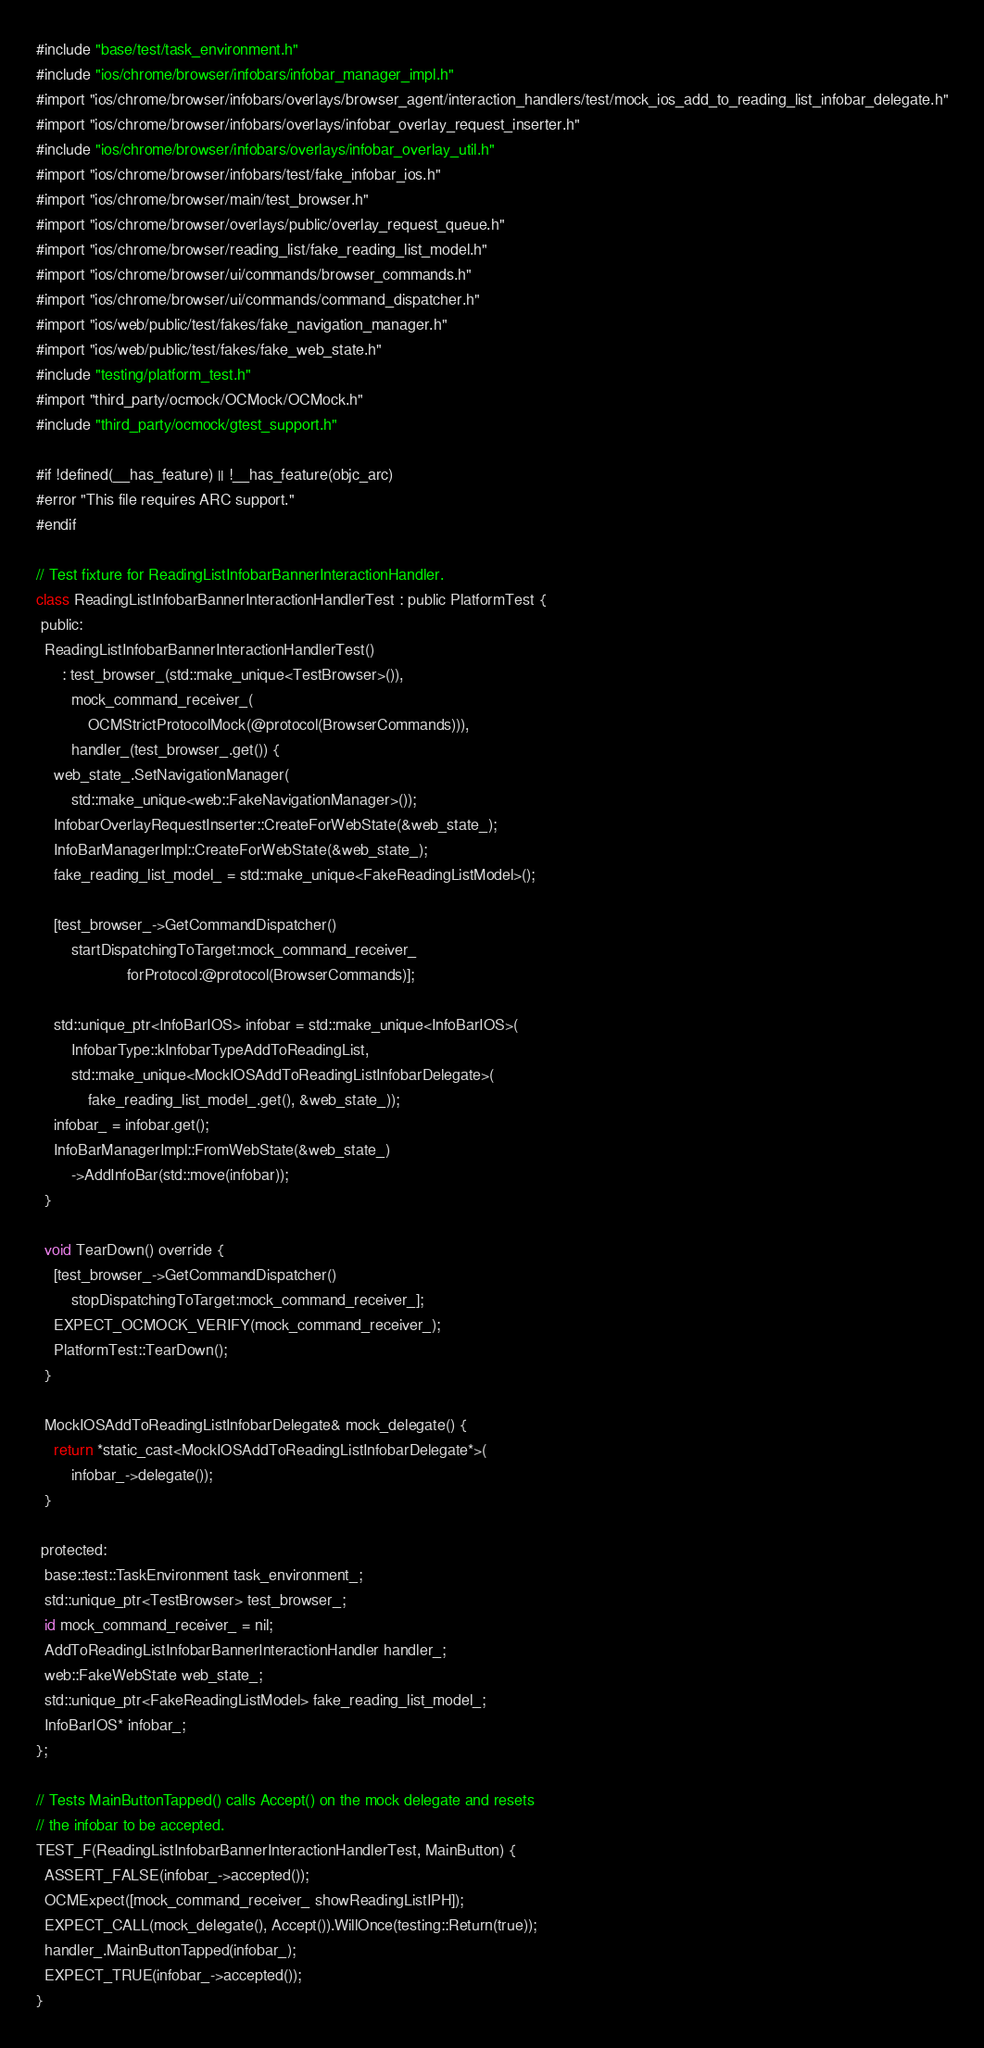<code> <loc_0><loc_0><loc_500><loc_500><_ObjectiveC_>#include "base/test/task_environment.h"
#include "ios/chrome/browser/infobars/infobar_manager_impl.h"
#import "ios/chrome/browser/infobars/overlays/browser_agent/interaction_handlers/test/mock_ios_add_to_reading_list_infobar_delegate.h"
#import "ios/chrome/browser/infobars/overlays/infobar_overlay_request_inserter.h"
#include "ios/chrome/browser/infobars/overlays/infobar_overlay_util.h"
#import "ios/chrome/browser/infobars/test/fake_infobar_ios.h"
#import "ios/chrome/browser/main/test_browser.h"
#import "ios/chrome/browser/overlays/public/overlay_request_queue.h"
#import "ios/chrome/browser/reading_list/fake_reading_list_model.h"
#import "ios/chrome/browser/ui/commands/browser_commands.h"
#import "ios/chrome/browser/ui/commands/command_dispatcher.h"
#import "ios/web/public/test/fakes/fake_navigation_manager.h"
#import "ios/web/public/test/fakes/fake_web_state.h"
#include "testing/platform_test.h"
#import "third_party/ocmock/OCMock/OCMock.h"
#include "third_party/ocmock/gtest_support.h"

#if !defined(__has_feature) || !__has_feature(objc_arc)
#error "This file requires ARC support."
#endif

// Test fixture for ReadingListInfobarBannerInteractionHandler.
class ReadingListInfobarBannerInteractionHandlerTest : public PlatformTest {
 public:
  ReadingListInfobarBannerInteractionHandlerTest()
      : test_browser_(std::make_unique<TestBrowser>()),
        mock_command_receiver_(
            OCMStrictProtocolMock(@protocol(BrowserCommands))),
        handler_(test_browser_.get()) {
    web_state_.SetNavigationManager(
        std::make_unique<web::FakeNavigationManager>());
    InfobarOverlayRequestInserter::CreateForWebState(&web_state_);
    InfoBarManagerImpl::CreateForWebState(&web_state_);
    fake_reading_list_model_ = std::make_unique<FakeReadingListModel>();

    [test_browser_->GetCommandDispatcher()
        startDispatchingToTarget:mock_command_receiver_
                     forProtocol:@protocol(BrowserCommands)];

    std::unique_ptr<InfoBarIOS> infobar = std::make_unique<InfoBarIOS>(
        InfobarType::kInfobarTypeAddToReadingList,
        std::make_unique<MockIOSAddToReadingListInfobarDelegate>(
            fake_reading_list_model_.get(), &web_state_));
    infobar_ = infobar.get();
    InfoBarManagerImpl::FromWebState(&web_state_)
        ->AddInfoBar(std::move(infobar));
  }

  void TearDown() override {
    [test_browser_->GetCommandDispatcher()
        stopDispatchingToTarget:mock_command_receiver_];
    EXPECT_OCMOCK_VERIFY(mock_command_receiver_);
    PlatformTest::TearDown();
  }

  MockIOSAddToReadingListInfobarDelegate& mock_delegate() {
    return *static_cast<MockIOSAddToReadingListInfobarDelegate*>(
        infobar_->delegate());
  }

 protected:
  base::test::TaskEnvironment task_environment_;
  std::unique_ptr<TestBrowser> test_browser_;
  id mock_command_receiver_ = nil;
  AddToReadingListInfobarBannerInteractionHandler handler_;
  web::FakeWebState web_state_;
  std::unique_ptr<FakeReadingListModel> fake_reading_list_model_;
  InfoBarIOS* infobar_;
};

// Tests MainButtonTapped() calls Accept() on the mock delegate and resets
// the infobar to be accepted.
TEST_F(ReadingListInfobarBannerInteractionHandlerTest, MainButton) {
  ASSERT_FALSE(infobar_->accepted());
  OCMExpect([mock_command_receiver_ showReadingListIPH]);
  EXPECT_CALL(mock_delegate(), Accept()).WillOnce(testing::Return(true));
  handler_.MainButtonTapped(infobar_);
  EXPECT_TRUE(infobar_->accepted());
}
</code> 